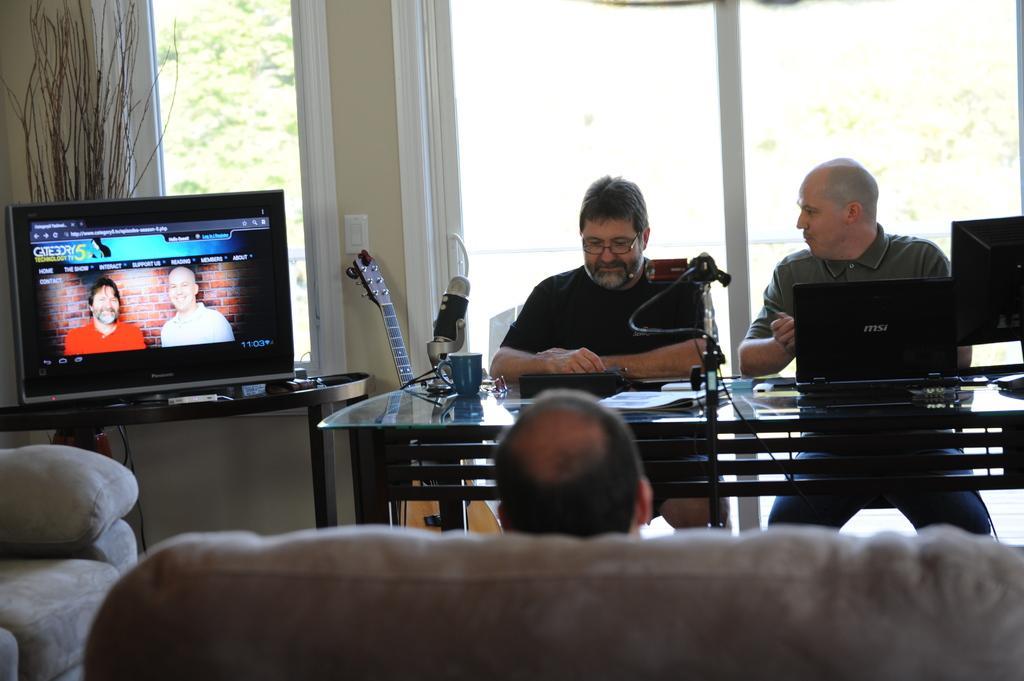Please provide a concise description of this image. In this image I can see three pole. One person is sitting on the couch and two people are sitting in-front of the table. On the table I can see papers, cup, laptop, system and some objects. To the left I can see the television on the table. To the side of the television I can see the musical instrument. In the back there is a window. 